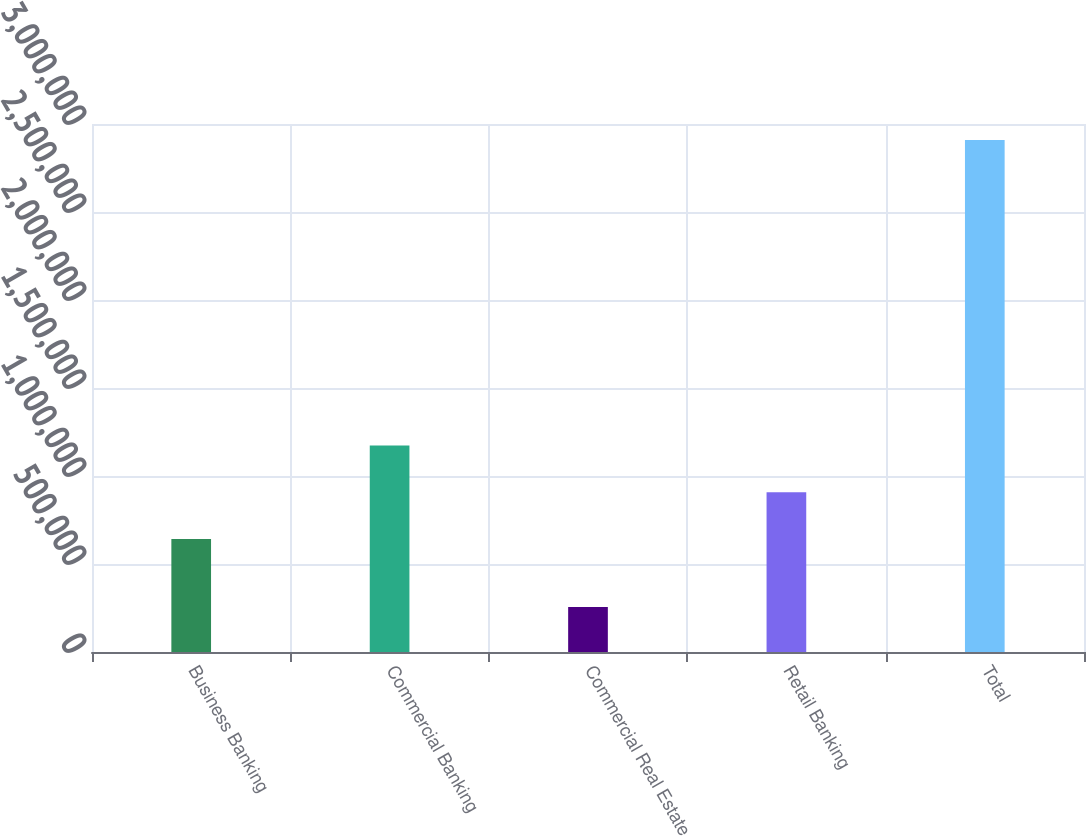Convert chart to OTSL. <chart><loc_0><loc_0><loc_500><loc_500><bar_chart><fcel>Business Banking<fcel>Commercial Banking<fcel>Commercial Real Estate<fcel>Retail Banking<fcel>Total<nl><fcel>642103<fcel>1.17284e+06<fcel>255166<fcel>907471<fcel>2.90885e+06<nl></chart> 